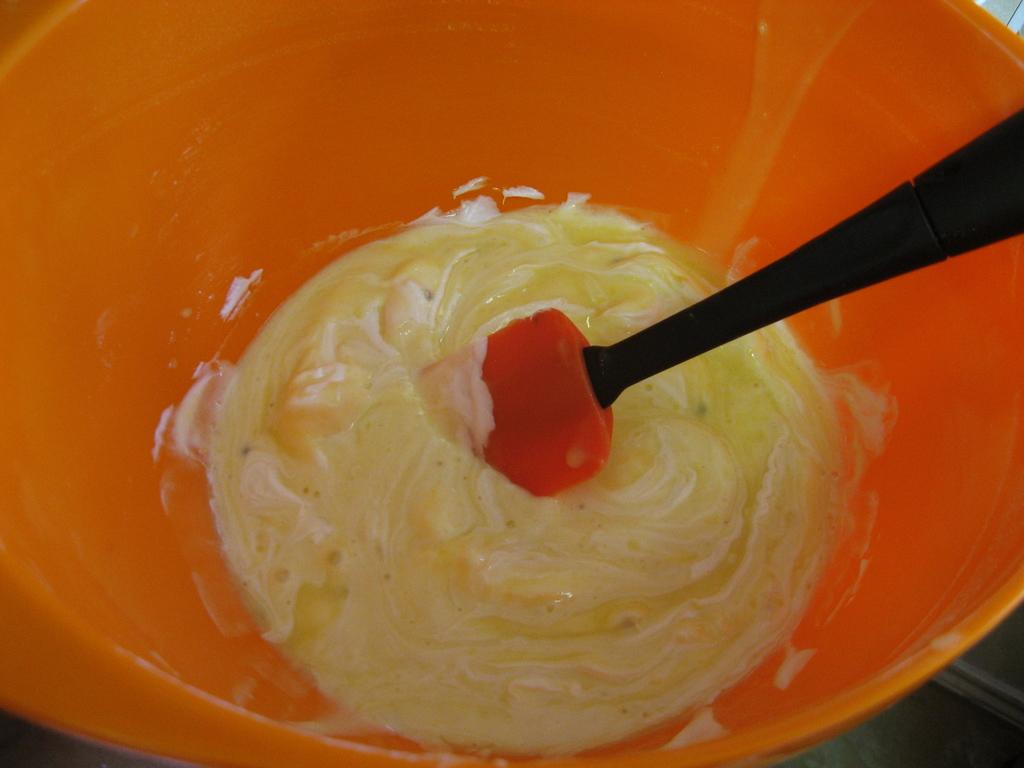What color is the bowl in the image? The bowl in the image is orange-colored. What is inside the bowl? There is cream in the bowl. What utensil is present in the bowl? There is a spoon in the bowl. How many ladybugs are crawling on the spoon in the image? There are no ladybugs present in the image; the spoon is in a bowl of cream. 